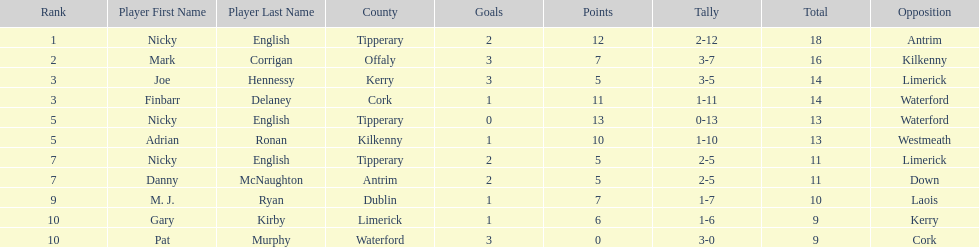How many times was waterford the opposition? 2. 